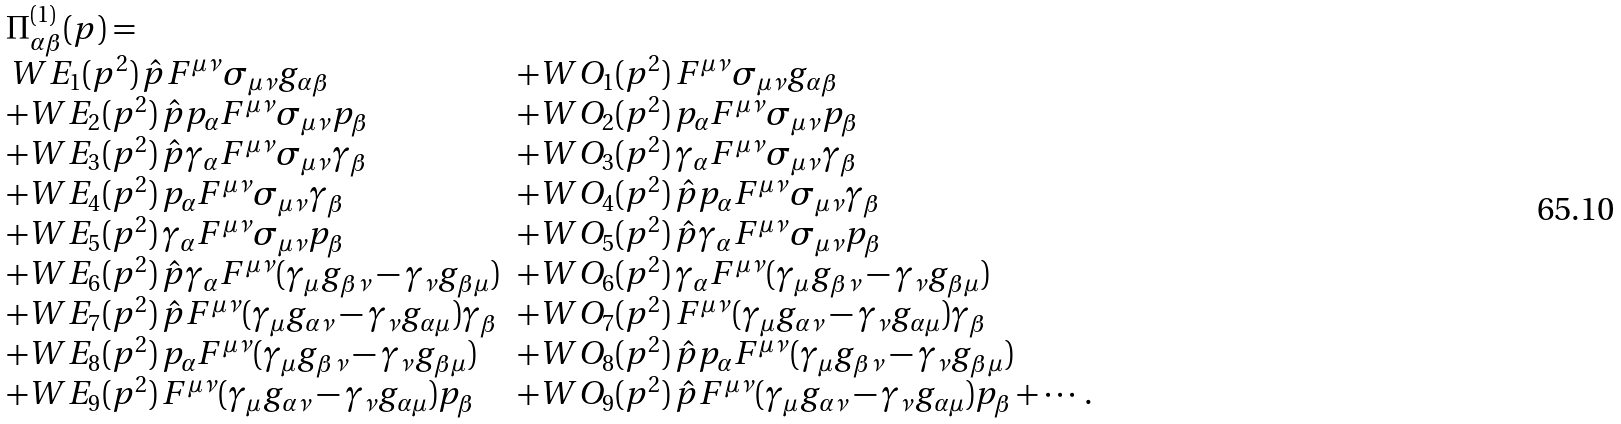Convert formula to latex. <formula><loc_0><loc_0><loc_500><loc_500>\begin{array} { l l } \Pi ^ { ( 1 ) } _ { \alpha \beta } ( p ) = \\ \, W E _ { 1 } ( p ^ { 2 } ) \, \hat { p } F ^ { \mu \nu } \sigma _ { \mu \nu } g _ { \alpha \beta } & + W O _ { 1 } ( p ^ { 2 } ) \, F ^ { \mu \nu } \sigma _ { \mu \nu } g _ { \alpha \beta } \\ + W E _ { 2 } ( p ^ { 2 } ) \, \hat { p } p _ { \alpha } F ^ { \mu \nu } \sigma _ { \mu \nu } p _ { \beta } & + W O _ { 2 } ( p ^ { 2 } ) \, p _ { \alpha } F ^ { \mu \nu } \sigma _ { \mu \nu } p _ { \beta } \\ + W E _ { 3 } ( p ^ { 2 } ) \, \hat { p } \gamma _ { \alpha } F ^ { \mu \nu } \sigma _ { \mu \nu } \gamma _ { \beta } & + W O _ { 3 } ( p ^ { 2 } ) \, \gamma _ { \alpha } F ^ { \mu \nu } \sigma _ { \mu \nu } \gamma _ { \beta } \\ + W E _ { 4 } ( p ^ { 2 } ) \, p _ { \alpha } F ^ { \mu \nu } \sigma _ { \mu \nu } \gamma _ { \beta } & + W O _ { 4 } ( p ^ { 2 } ) \, \hat { p } p _ { \alpha } F ^ { \mu \nu } \sigma _ { \mu \nu } \gamma _ { \beta } \\ + W E _ { 5 } ( p ^ { 2 } ) \, \gamma _ { \alpha } F ^ { \mu \nu } \sigma _ { \mu \nu } p _ { \beta } & + W O _ { 5 } ( p ^ { 2 } ) \, \hat { p } \gamma _ { \alpha } F ^ { \mu \nu } \sigma _ { \mu \nu } p _ { \beta } \\ + W E _ { 6 } ( p ^ { 2 } ) \, \hat { p } \gamma _ { \alpha } F ^ { \mu \nu } ( \gamma _ { \mu } g _ { \beta \nu } - \gamma _ { \nu } g _ { \beta \mu } ) & + W O _ { 6 } ( p ^ { 2 } ) \, \gamma _ { \alpha } F ^ { \mu \nu } ( \gamma _ { \mu } g _ { \beta \nu } - \gamma _ { \nu } g _ { \beta \mu } ) \\ + W E _ { 7 } ( p ^ { 2 } ) \, \hat { p } F ^ { \mu \nu } ( \gamma _ { \mu } g _ { \alpha \nu } - \gamma _ { \nu } g _ { \alpha \mu } ) \gamma _ { \beta } & + W O _ { 7 } ( p ^ { 2 } ) \, F ^ { \mu \nu } ( \gamma _ { \mu } g _ { \alpha \nu } - \gamma _ { \nu } g _ { \alpha \mu } ) \gamma _ { \beta } \\ + W E _ { 8 } ( p ^ { 2 } ) \, p _ { \alpha } F ^ { \mu \nu } ( \gamma _ { \mu } g _ { \beta \nu } - \gamma _ { \nu } g _ { \beta \mu } ) & + W O _ { 8 } ( p ^ { 2 } ) \, \hat { p } p _ { \alpha } F ^ { \mu \nu } ( \gamma _ { \mu } g _ { \beta \nu } - \gamma _ { \nu } g _ { \beta \mu } ) \\ + W E _ { 9 } ( p ^ { 2 } ) \, F ^ { \mu \nu } ( \gamma _ { \mu } g _ { \alpha \nu } - \gamma _ { \nu } g _ { \alpha \mu } ) p _ { \beta } & + W O _ { 9 } ( p ^ { 2 } ) \, \hat { p } F ^ { \mu \nu } ( \gamma _ { \mu } g _ { \alpha \nu } - \gamma _ { \nu } g _ { \alpha \mu } ) p _ { \beta } + \cdots . \end{array}</formula> 